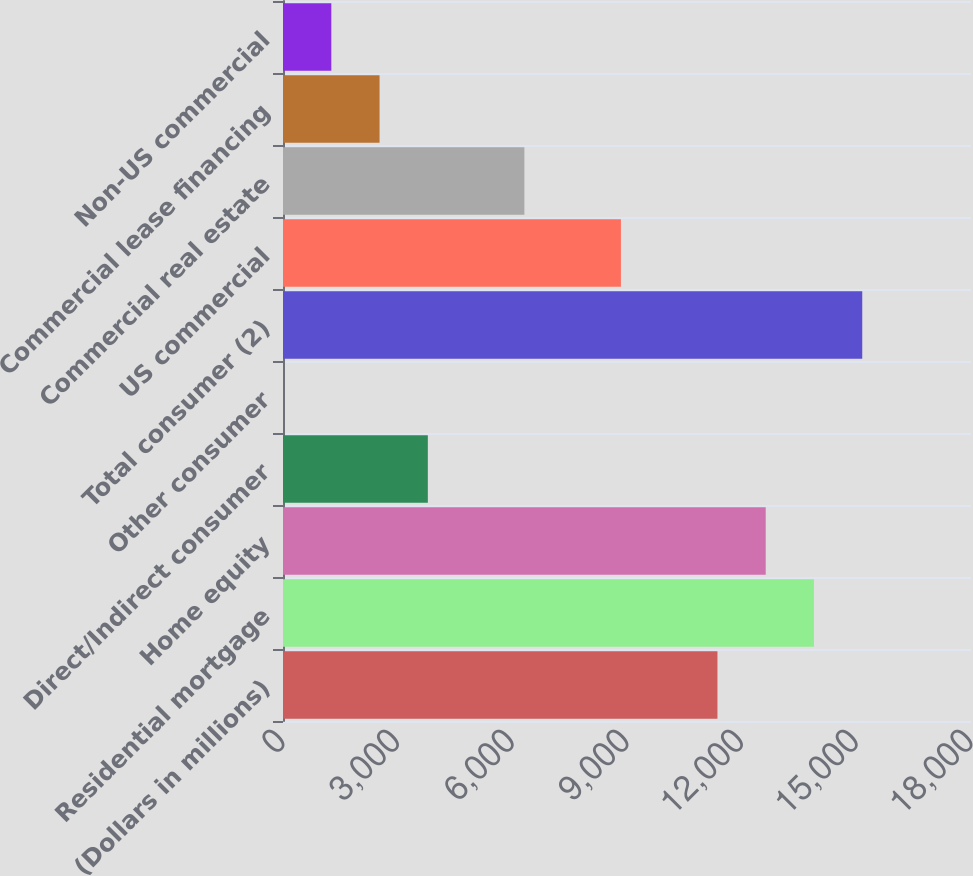Convert chart. <chart><loc_0><loc_0><loc_500><loc_500><bar_chart><fcel>(Dollars in millions)<fcel>Residential mortgage<fcel>Home equity<fcel>Direct/Indirect consumer<fcel>Other consumer<fcel>Total consumer (2)<fcel>US commercial<fcel>Commercial real estate<fcel>Commercial lease financing<fcel>Non-US commercial<nl><fcel>11366.2<fcel>13891.8<fcel>12629<fcel>3789.4<fcel>1<fcel>15154.6<fcel>8840.6<fcel>6315<fcel>2526.6<fcel>1263.8<nl></chart> 